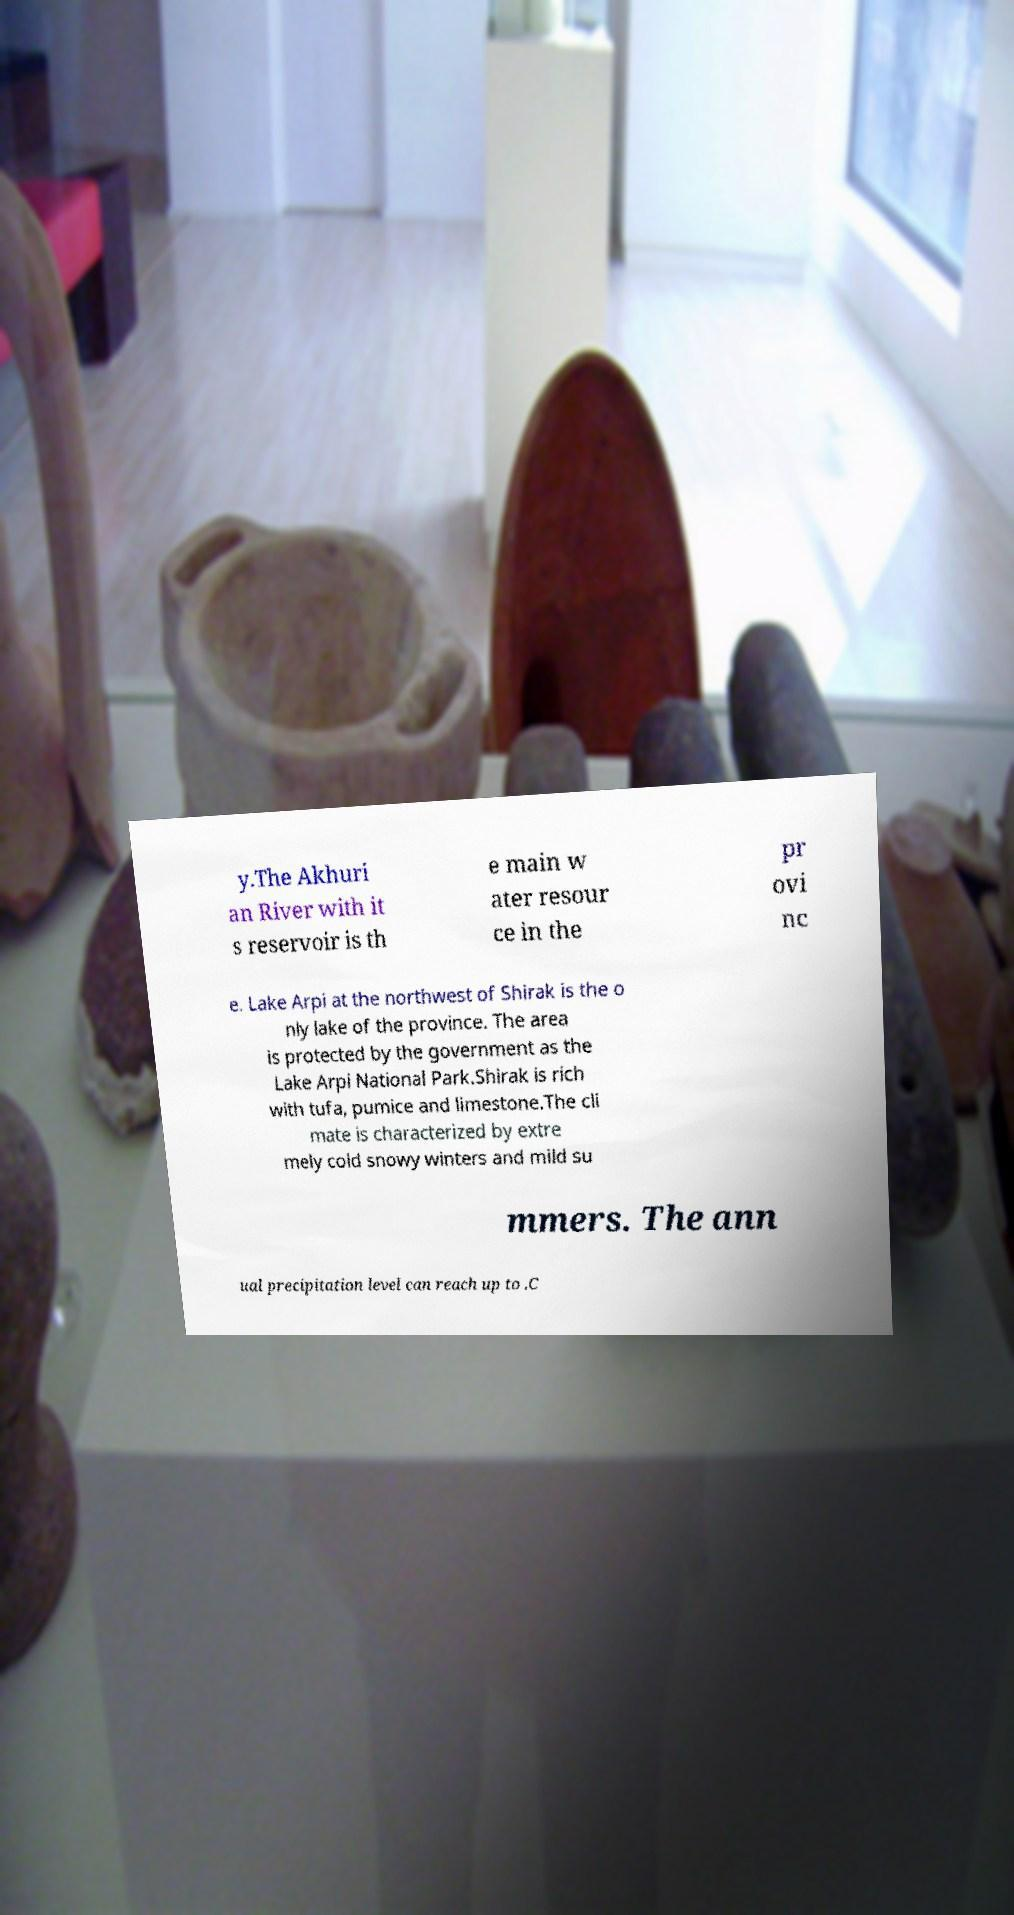Can you read and provide the text displayed in the image?This photo seems to have some interesting text. Can you extract and type it out for me? y.The Akhuri an River with it s reservoir is th e main w ater resour ce in the pr ovi nc e. Lake Arpi at the northwest of Shirak is the o nly lake of the province. The area is protected by the government as the Lake Arpi National Park.Shirak is rich with tufa, pumice and limestone.The cli mate is characterized by extre mely cold snowy winters and mild su mmers. The ann ual precipitation level can reach up to .C 